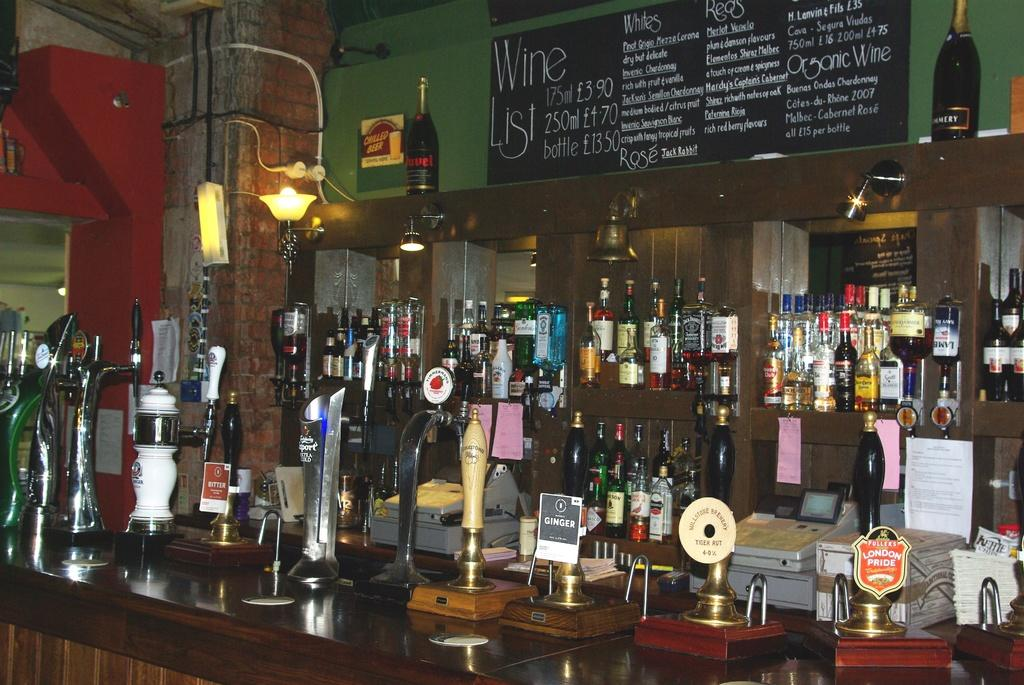What is the primary subject of the image? The primary subject of the image is many wine bottles. Can you describe any other objects on the table in the image? There are other objects on the table in the image, but their specific details are not mentioned in the provided facts. How many times does the bed crack in the image? There is no bed present in the image, so the question cannot be answered. 